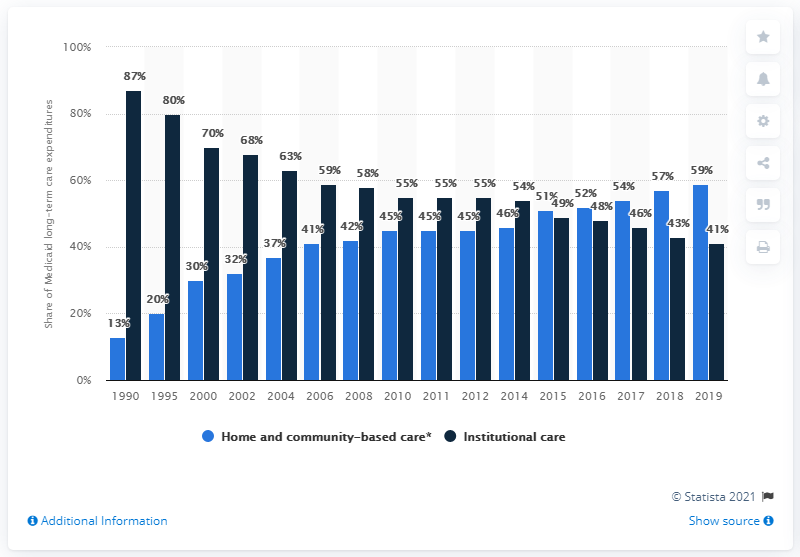List a handful of essential elements in this visual. In 1990, approximately 13% of Medicaid's long-term care costs were allocated towards home- and community-based care. 